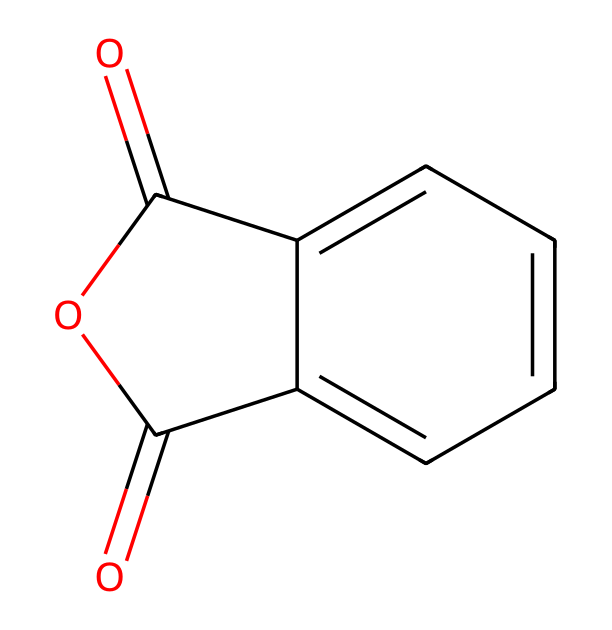What is the name of this chemical? The provided SMILES representation corresponds to a compound known as phthalic anhydride, which is characterized by its structure containing an anhydride functional group derived from phthalic acid.
Answer: phthalic anhydride How many carbon atoms are in phthalic anhydride? Analyzing the SMILES structure, there are a total of eight carbon atoms present in the molecule as indicated by the 'c' (for aromatic) and 'C' (for non-aromatic) in the structure.
Answer: eight What is the functional group present in phthalic anhydride? The structure indicates that phthalic anhydride contains an anhydride functional group, recognizable from the cyclic arrangement of the carbonyl (C=O) groups attached to an oxygen atom.
Answer: anhydride How many pi bonds are present in phthalic anhydride? In the structure, there are four double bonds (each representing a pi bond); two from the carbonyl groups and two from the aromatic rings, totaling four pi bonds in the molecule.
Answer: four What type of chemical reaction can phthalic anhydride undergo with alcohols? Phthalic anhydride can undergo a reaction known as esterification when it reacts with alcohols, forming esters as a result of the nucleophilic attack of the alcohol on the carbonyl carbon.
Answer: esterification What is the state of phthalic anhydride at room temperature? Phthalic anhydride is typically a solid at room temperature, which is indicated by its common usage in powder form in resins and coatings, especially in industrial applications.
Answer: solid What is the primary use of phthalic anhydride in epoxy resins? Phthalic anhydride is primarily used as a hardener or curing agent in epoxy resins, which helps in crosslinking and improving the mechanical and thermal properties of the final coating.
Answer: hardener 